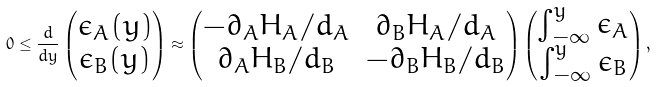<formula> <loc_0><loc_0><loc_500><loc_500>0 \leq \frac { d } { d y } \begin{pmatrix} \epsilon _ { A } ( y ) \\ \epsilon _ { B } ( y ) \end{pmatrix} \approx \begin{pmatrix} - \partial _ { A } H _ { A } / d _ { A } & \partial _ { B } H _ { A } / d _ { A } \\ \partial _ { A } H _ { B } / d _ { B } & - \partial _ { B } H _ { B } / d _ { B } \end{pmatrix} \begin{pmatrix} \int _ { - \infty } ^ { y } \epsilon _ { A } \\ \int _ { - \infty } ^ { y } \epsilon _ { B } \end{pmatrix} ,</formula> 